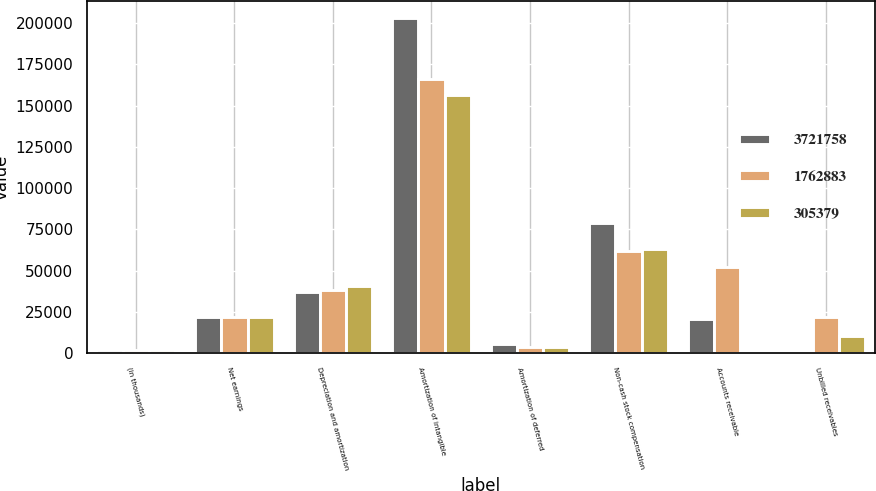<chart> <loc_0><loc_0><loc_500><loc_500><stacked_bar_chart><ecel><fcel>(in thousands)<fcel>Net earnings<fcel>Depreciation and amortization<fcel>Amortization of intangible<fcel>Amortization of deferred<fcel>Non-cash stock compensation<fcel>Accounts receivable<fcel>Unbilled receivables<nl><fcel>3.72176e+06<fcel>2016<fcel>21844<fcel>37299<fcel>203154<fcel>5612<fcel>78827<fcel>20734<fcel>1202<nl><fcel>1.76288e+06<fcel>2015<fcel>21844<fcel>38185<fcel>166076<fcel>4136<fcel>61766<fcel>52597<fcel>21844<nl><fcel>305379<fcel>2014<fcel>21844<fcel>40890<fcel>156394<fcel>4003<fcel>63027<fcel>404<fcel>10305<nl></chart> 